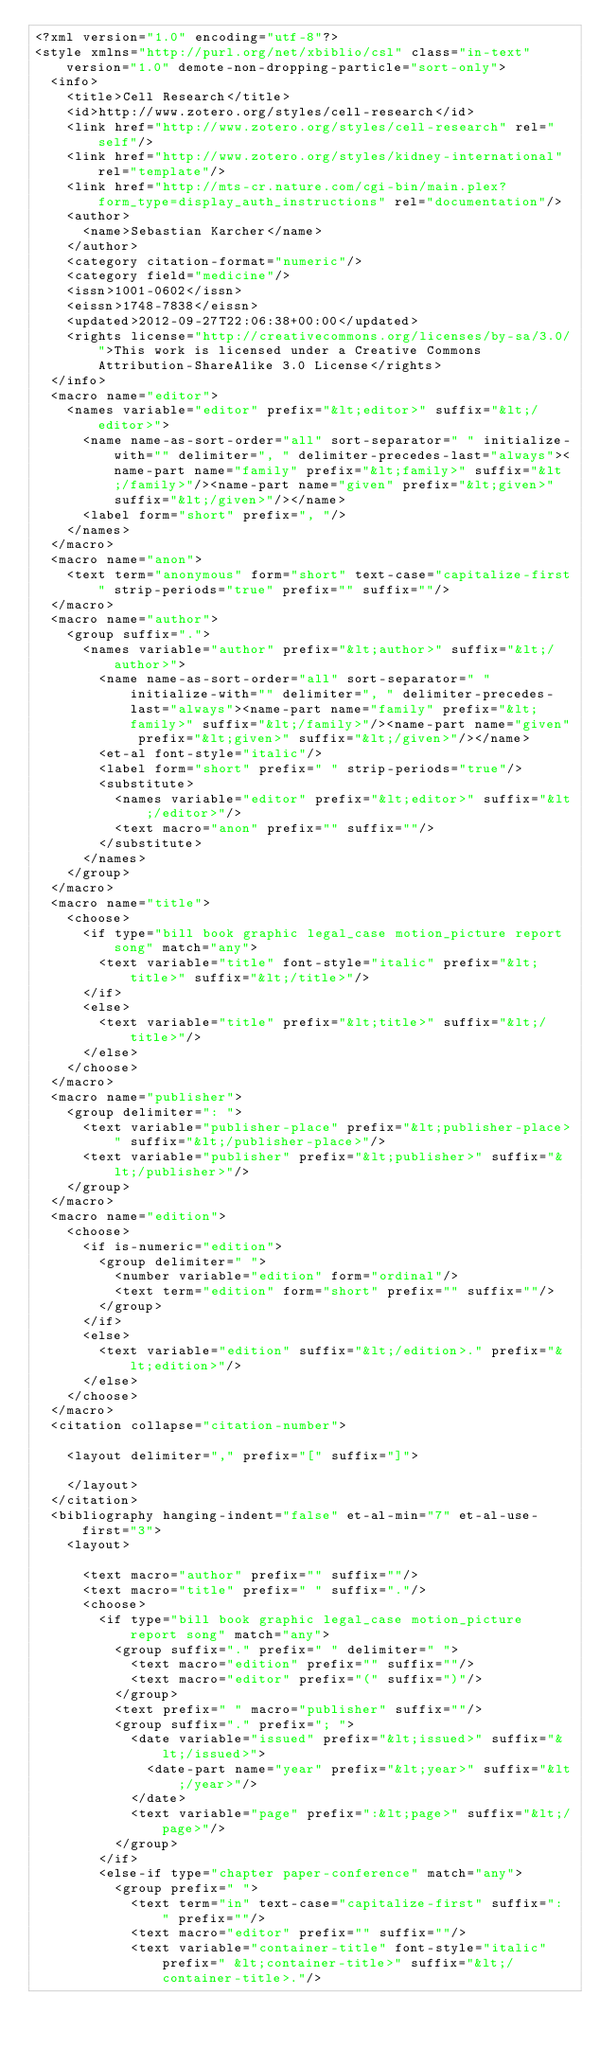Convert code to text. <code><loc_0><loc_0><loc_500><loc_500><_XML_><?xml version="1.0" encoding="utf-8"?>
<style xmlns="http://purl.org/net/xbiblio/csl" class="in-text" version="1.0" demote-non-dropping-particle="sort-only">
  <info>
    <title>Cell Research</title>
    <id>http://www.zotero.org/styles/cell-research</id>
    <link href="http://www.zotero.org/styles/cell-research" rel="self"/>
    <link href="http://www.zotero.org/styles/kidney-international" rel="template"/>
    <link href="http://mts-cr.nature.com/cgi-bin/main.plex?form_type=display_auth_instructions" rel="documentation"/>
    <author>
      <name>Sebastian Karcher</name>
    </author>
    <category citation-format="numeric"/>
    <category field="medicine"/>
    <issn>1001-0602</issn>
    <eissn>1748-7838</eissn>
    <updated>2012-09-27T22:06:38+00:00</updated>
    <rights license="http://creativecommons.org/licenses/by-sa/3.0/">This work is licensed under a Creative Commons Attribution-ShareAlike 3.0 License</rights>
  </info>
  <macro name="editor">
    <names variable="editor" prefix="&lt;editor>" suffix="&lt;/editor>">
      <name name-as-sort-order="all" sort-separator=" " initialize-with="" delimiter=", " delimiter-precedes-last="always"><name-part name="family" prefix="&lt;family>" suffix="&lt;/family>"/><name-part name="given" prefix="&lt;given>" suffix="&lt;/given>"/></name>
      <label form="short" prefix=", "/>
    </names>
  </macro>
  <macro name="anon">
    <text term="anonymous" form="short" text-case="capitalize-first" strip-periods="true" prefix="" suffix=""/>
  </macro>
  <macro name="author">
    <group suffix=".">
      <names variable="author" prefix="&lt;author>" suffix="&lt;/author>">
        <name name-as-sort-order="all" sort-separator=" " initialize-with="" delimiter=", " delimiter-precedes-last="always"><name-part name="family" prefix="&lt;family>" suffix="&lt;/family>"/><name-part name="given" prefix="&lt;given>" suffix="&lt;/given>"/></name>
        <et-al font-style="italic"/>
        <label form="short" prefix=" " strip-periods="true"/>
        <substitute>
          <names variable="editor" prefix="&lt;editor>" suffix="&lt;/editor>"/>
          <text macro="anon" prefix="" suffix=""/>
        </substitute>
      </names>
    </group>
  </macro>
  <macro name="title">
    <choose>
      <if type="bill book graphic legal_case motion_picture report song" match="any">
        <text variable="title" font-style="italic" prefix="&lt;title>" suffix="&lt;/title>"/>
      </if>
      <else>
        <text variable="title" prefix="&lt;title>" suffix="&lt;/title>"/>
      </else>
    </choose>
  </macro>
  <macro name="publisher">
    <group delimiter=": ">
      <text variable="publisher-place" prefix="&lt;publisher-place>" suffix="&lt;/publisher-place>"/>
      <text variable="publisher" prefix="&lt;publisher>" suffix="&lt;/publisher>"/>
    </group>
  </macro>
  <macro name="edition">
    <choose>
      <if is-numeric="edition">
        <group delimiter=" ">
          <number variable="edition" form="ordinal"/>
          <text term="edition" form="short" prefix="" suffix=""/>
        </group>
      </if>
      <else>
        <text variable="edition" suffix="&lt;/edition>." prefix="&lt;edition>"/>
      </else>
    </choose>
  </macro>
  <citation collapse="citation-number">
    
    <layout delimiter="," prefix="[" suffix="]">
      
    </layout>
  </citation>
  <bibliography hanging-indent="false" et-al-min="7" et-al-use-first="3">
    <layout>
      
      <text macro="author" prefix="" suffix=""/>
      <text macro="title" prefix=" " suffix="."/>
      <choose>
        <if type="bill book graphic legal_case motion_picture report song" match="any">
          <group suffix="." prefix=" " delimiter=" ">
            <text macro="edition" prefix="" suffix=""/>
            <text macro="editor" prefix="(" suffix=")"/>
          </group>
          <text prefix=" " macro="publisher" suffix=""/>
          <group suffix="." prefix="; ">
            <date variable="issued" prefix="&lt;issued>" suffix="&lt;/issued>">
              <date-part name="year" prefix="&lt;year>" suffix="&lt;/year>"/>
            </date>
            <text variable="page" prefix=":&lt;page>" suffix="&lt;/page>"/>
          </group>
        </if>
        <else-if type="chapter paper-conference" match="any">
          <group prefix=" ">
            <text term="in" text-case="capitalize-first" suffix=": " prefix=""/>
            <text macro="editor" prefix="" suffix=""/>
            <text variable="container-title" font-style="italic" prefix=" &lt;container-title>" suffix="&lt;/container-title>."/></code> 